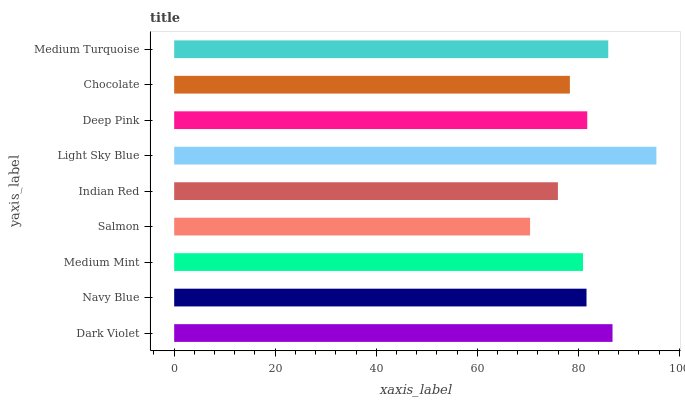Is Salmon the minimum?
Answer yes or no. Yes. Is Light Sky Blue the maximum?
Answer yes or no. Yes. Is Navy Blue the minimum?
Answer yes or no. No. Is Navy Blue the maximum?
Answer yes or no. No. Is Dark Violet greater than Navy Blue?
Answer yes or no. Yes. Is Navy Blue less than Dark Violet?
Answer yes or no. Yes. Is Navy Blue greater than Dark Violet?
Answer yes or no. No. Is Dark Violet less than Navy Blue?
Answer yes or no. No. Is Navy Blue the high median?
Answer yes or no. Yes. Is Navy Blue the low median?
Answer yes or no. Yes. Is Medium Turquoise the high median?
Answer yes or no. No. Is Salmon the low median?
Answer yes or no. No. 